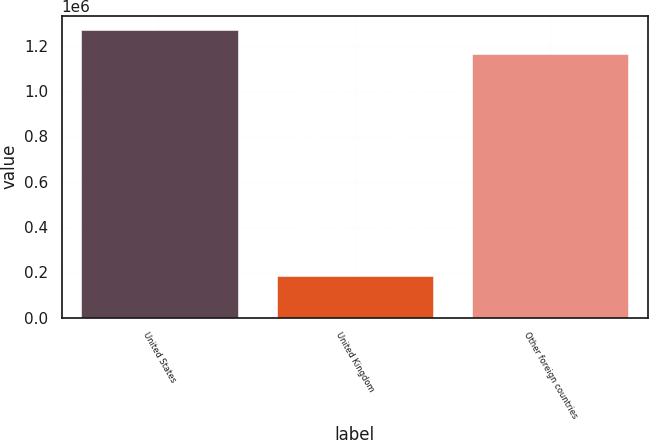<chart> <loc_0><loc_0><loc_500><loc_500><bar_chart><fcel>United States<fcel>United Kingdom<fcel>Other foreign countries<nl><fcel>1.26814e+06<fcel>184295<fcel>1.16302e+06<nl></chart> 